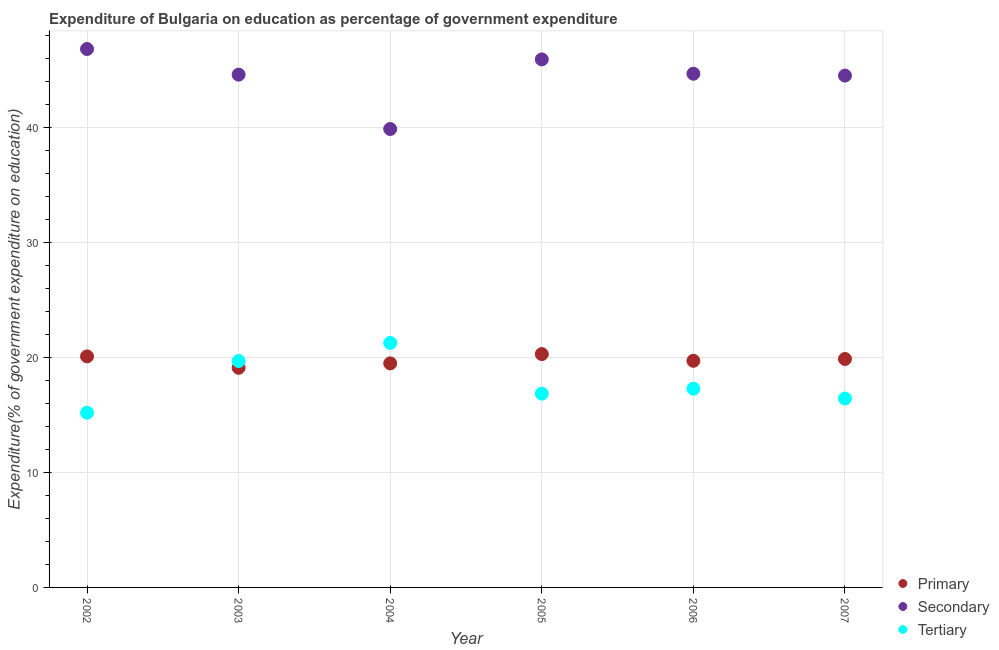How many different coloured dotlines are there?
Provide a short and direct response. 3. What is the expenditure on secondary education in 2005?
Your answer should be compact. 45.94. Across all years, what is the maximum expenditure on primary education?
Ensure brevity in your answer.  20.3. Across all years, what is the minimum expenditure on secondary education?
Provide a short and direct response. 39.88. In which year was the expenditure on secondary education maximum?
Your answer should be very brief. 2002. In which year was the expenditure on primary education minimum?
Your response must be concise. 2003. What is the total expenditure on secondary education in the graph?
Your answer should be very brief. 266.48. What is the difference between the expenditure on tertiary education in 2002 and that in 2003?
Provide a short and direct response. -4.5. What is the difference between the expenditure on primary education in 2007 and the expenditure on tertiary education in 2006?
Offer a terse response. 2.58. What is the average expenditure on tertiary education per year?
Your answer should be compact. 17.79. In the year 2005, what is the difference between the expenditure on tertiary education and expenditure on secondary education?
Provide a succinct answer. -29.08. What is the ratio of the expenditure on primary education in 2002 to that in 2005?
Give a very brief answer. 0.99. What is the difference between the highest and the second highest expenditure on tertiary education?
Provide a succinct answer. 1.58. What is the difference between the highest and the lowest expenditure on secondary education?
Offer a terse response. 6.96. Is it the case that in every year, the sum of the expenditure on primary education and expenditure on secondary education is greater than the expenditure on tertiary education?
Your response must be concise. Yes. How many dotlines are there?
Your response must be concise. 3. How many legend labels are there?
Offer a very short reply. 3. How are the legend labels stacked?
Your answer should be very brief. Vertical. What is the title of the graph?
Provide a short and direct response. Expenditure of Bulgaria on education as percentage of government expenditure. What is the label or title of the X-axis?
Make the answer very short. Year. What is the label or title of the Y-axis?
Give a very brief answer. Expenditure(% of government expenditure on education). What is the Expenditure(% of government expenditure on education) in Primary in 2002?
Keep it short and to the point. 20.1. What is the Expenditure(% of government expenditure on education) of Secondary in 2002?
Give a very brief answer. 46.84. What is the Expenditure(% of government expenditure on education) in Tertiary in 2002?
Keep it short and to the point. 15.19. What is the Expenditure(% of government expenditure on education) in Primary in 2003?
Offer a terse response. 19.11. What is the Expenditure(% of government expenditure on education) of Secondary in 2003?
Offer a terse response. 44.61. What is the Expenditure(% of government expenditure on education) in Tertiary in 2003?
Keep it short and to the point. 19.7. What is the Expenditure(% of government expenditure on education) in Primary in 2004?
Your response must be concise. 19.49. What is the Expenditure(% of government expenditure on education) of Secondary in 2004?
Offer a very short reply. 39.88. What is the Expenditure(% of government expenditure on education) of Tertiary in 2004?
Offer a very short reply. 21.27. What is the Expenditure(% of government expenditure on education) of Primary in 2005?
Offer a terse response. 20.3. What is the Expenditure(% of government expenditure on education) in Secondary in 2005?
Give a very brief answer. 45.94. What is the Expenditure(% of government expenditure on education) in Tertiary in 2005?
Provide a succinct answer. 16.86. What is the Expenditure(% of government expenditure on education) in Primary in 2006?
Your answer should be compact. 19.72. What is the Expenditure(% of government expenditure on education) in Secondary in 2006?
Offer a terse response. 44.69. What is the Expenditure(% of government expenditure on education) in Tertiary in 2006?
Offer a very short reply. 17.29. What is the Expenditure(% of government expenditure on education) of Primary in 2007?
Provide a short and direct response. 19.87. What is the Expenditure(% of government expenditure on education) in Secondary in 2007?
Offer a very short reply. 44.53. What is the Expenditure(% of government expenditure on education) of Tertiary in 2007?
Provide a short and direct response. 16.43. Across all years, what is the maximum Expenditure(% of government expenditure on education) in Primary?
Make the answer very short. 20.3. Across all years, what is the maximum Expenditure(% of government expenditure on education) of Secondary?
Your response must be concise. 46.84. Across all years, what is the maximum Expenditure(% of government expenditure on education) of Tertiary?
Keep it short and to the point. 21.27. Across all years, what is the minimum Expenditure(% of government expenditure on education) in Primary?
Provide a short and direct response. 19.11. Across all years, what is the minimum Expenditure(% of government expenditure on education) of Secondary?
Your answer should be very brief. 39.88. Across all years, what is the minimum Expenditure(% of government expenditure on education) of Tertiary?
Your answer should be compact. 15.19. What is the total Expenditure(% of government expenditure on education) of Primary in the graph?
Provide a succinct answer. 118.59. What is the total Expenditure(% of government expenditure on education) of Secondary in the graph?
Offer a terse response. 266.48. What is the total Expenditure(% of government expenditure on education) in Tertiary in the graph?
Ensure brevity in your answer.  106.74. What is the difference between the Expenditure(% of government expenditure on education) in Primary in 2002 and that in 2003?
Make the answer very short. 0.99. What is the difference between the Expenditure(% of government expenditure on education) in Secondary in 2002 and that in 2003?
Keep it short and to the point. 2.23. What is the difference between the Expenditure(% of government expenditure on education) of Tertiary in 2002 and that in 2003?
Offer a terse response. -4.5. What is the difference between the Expenditure(% of government expenditure on education) of Primary in 2002 and that in 2004?
Your response must be concise. 0.61. What is the difference between the Expenditure(% of government expenditure on education) in Secondary in 2002 and that in 2004?
Keep it short and to the point. 6.96. What is the difference between the Expenditure(% of government expenditure on education) of Tertiary in 2002 and that in 2004?
Your response must be concise. -6.08. What is the difference between the Expenditure(% of government expenditure on education) in Primary in 2002 and that in 2005?
Offer a terse response. -0.2. What is the difference between the Expenditure(% of government expenditure on education) of Secondary in 2002 and that in 2005?
Keep it short and to the point. 0.9. What is the difference between the Expenditure(% of government expenditure on education) of Tertiary in 2002 and that in 2005?
Provide a short and direct response. -1.67. What is the difference between the Expenditure(% of government expenditure on education) of Primary in 2002 and that in 2006?
Ensure brevity in your answer.  0.38. What is the difference between the Expenditure(% of government expenditure on education) in Secondary in 2002 and that in 2006?
Offer a terse response. 2.15. What is the difference between the Expenditure(% of government expenditure on education) in Tertiary in 2002 and that in 2006?
Offer a very short reply. -2.09. What is the difference between the Expenditure(% of government expenditure on education) in Primary in 2002 and that in 2007?
Your answer should be compact. 0.23. What is the difference between the Expenditure(% of government expenditure on education) in Secondary in 2002 and that in 2007?
Offer a terse response. 2.31. What is the difference between the Expenditure(% of government expenditure on education) in Tertiary in 2002 and that in 2007?
Your response must be concise. -1.24. What is the difference between the Expenditure(% of government expenditure on education) in Primary in 2003 and that in 2004?
Offer a very short reply. -0.39. What is the difference between the Expenditure(% of government expenditure on education) of Secondary in 2003 and that in 2004?
Your answer should be compact. 4.73. What is the difference between the Expenditure(% of government expenditure on education) of Tertiary in 2003 and that in 2004?
Ensure brevity in your answer.  -1.58. What is the difference between the Expenditure(% of government expenditure on education) in Primary in 2003 and that in 2005?
Offer a terse response. -1.19. What is the difference between the Expenditure(% of government expenditure on education) of Secondary in 2003 and that in 2005?
Provide a short and direct response. -1.33. What is the difference between the Expenditure(% of government expenditure on education) of Tertiary in 2003 and that in 2005?
Offer a terse response. 2.84. What is the difference between the Expenditure(% of government expenditure on education) of Primary in 2003 and that in 2006?
Keep it short and to the point. -0.61. What is the difference between the Expenditure(% of government expenditure on education) of Secondary in 2003 and that in 2006?
Offer a very short reply. -0.08. What is the difference between the Expenditure(% of government expenditure on education) of Tertiary in 2003 and that in 2006?
Give a very brief answer. 2.41. What is the difference between the Expenditure(% of government expenditure on education) in Primary in 2003 and that in 2007?
Your answer should be compact. -0.77. What is the difference between the Expenditure(% of government expenditure on education) in Secondary in 2003 and that in 2007?
Your answer should be very brief. 0.08. What is the difference between the Expenditure(% of government expenditure on education) in Tertiary in 2003 and that in 2007?
Your answer should be very brief. 3.26. What is the difference between the Expenditure(% of government expenditure on education) of Primary in 2004 and that in 2005?
Give a very brief answer. -0.81. What is the difference between the Expenditure(% of government expenditure on education) in Secondary in 2004 and that in 2005?
Your answer should be compact. -6.05. What is the difference between the Expenditure(% of government expenditure on education) in Tertiary in 2004 and that in 2005?
Ensure brevity in your answer.  4.41. What is the difference between the Expenditure(% of government expenditure on education) in Primary in 2004 and that in 2006?
Keep it short and to the point. -0.22. What is the difference between the Expenditure(% of government expenditure on education) of Secondary in 2004 and that in 2006?
Ensure brevity in your answer.  -4.81. What is the difference between the Expenditure(% of government expenditure on education) in Tertiary in 2004 and that in 2006?
Provide a short and direct response. 3.98. What is the difference between the Expenditure(% of government expenditure on education) in Primary in 2004 and that in 2007?
Ensure brevity in your answer.  -0.38. What is the difference between the Expenditure(% of government expenditure on education) in Secondary in 2004 and that in 2007?
Ensure brevity in your answer.  -4.65. What is the difference between the Expenditure(% of government expenditure on education) of Tertiary in 2004 and that in 2007?
Offer a terse response. 4.84. What is the difference between the Expenditure(% of government expenditure on education) in Primary in 2005 and that in 2006?
Ensure brevity in your answer.  0.58. What is the difference between the Expenditure(% of government expenditure on education) in Secondary in 2005 and that in 2006?
Your response must be concise. 1.25. What is the difference between the Expenditure(% of government expenditure on education) of Tertiary in 2005 and that in 2006?
Offer a very short reply. -0.43. What is the difference between the Expenditure(% of government expenditure on education) in Primary in 2005 and that in 2007?
Provide a short and direct response. 0.43. What is the difference between the Expenditure(% of government expenditure on education) of Secondary in 2005 and that in 2007?
Keep it short and to the point. 1.41. What is the difference between the Expenditure(% of government expenditure on education) of Tertiary in 2005 and that in 2007?
Give a very brief answer. 0.43. What is the difference between the Expenditure(% of government expenditure on education) of Primary in 2006 and that in 2007?
Provide a short and direct response. -0.16. What is the difference between the Expenditure(% of government expenditure on education) of Secondary in 2006 and that in 2007?
Make the answer very short. 0.16. What is the difference between the Expenditure(% of government expenditure on education) in Tertiary in 2006 and that in 2007?
Make the answer very short. 0.86. What is the difference between the Expenditure(% of government expenditure on education) in Primary in 2002 and the Expenditure(% of government expenditure on education) in Secondary in 2003?
Offer a very short reply. -24.51. What is the difference between the Expenditure(% of government expenditure on education) of Primary in 2002 and the Expenditure(% of government expenditure on education) of Tertiary in 2003?
Your response must be concise. 0.4. What is the difference between the Expenditure(% of government expenditure on education) of Secondary in 2002 and the Expenditure(% of government expenditure on education) of Tertiary in 2003?
Give a very brief answer. 27.14. What is the difference between the Expenditure(% of government expenditure on education) of Primary in 2002 and the Expenditure(% of government expenditure on education) of Secondary in 2004?
Provide a short and direct response. -19.78. What is the difference between the Expenditure(% of government expenditure on education) of Primary in 2002 and the Expenditure(% of government expenditure on education) of Tertiary in 2004?
Ensure brevity in your answer.  -1.17. What is the difference between the Expenditure(% of government expenditure on education) of Secondary in 2002 and the Expenditure(% of government expenditure on education) of Tertiary in 2004?
Make the answer very short. 25.57. What is the difference between the Expenditure(% of government expenditure on education) in Primary in 2002 and the Expenditure(% of government expenditure on education) in Secondary in 2005?
Your response must be concise. -25.84. What is the difference between the Expenditure(% of government expenditure on education) in Primary in 2002 and the Expenditure(% of government expenditure on education) in Tertiary in 2005?
Your answer should be very brief. 3.24. What is the difference between the Expenditure(% of government expenditure on education) in Secondary in 2002 and the Expenditure(% of government expenditure on education) in Tertiary in 2005?
Give a very brief answer. 29.98. What is the difference between the Expenditure(% of government expenditure on education) in Primary in 2002 and the Expenditure(% of government expenditure on education) in Secondary in 2006?
Ensure brevity in your answer.  -24.59. What is the difference between the Expenditure(% of government expenditure on education) in Primary in 2002 and the Expenditure(% of government expenditure on education) in Tertiary in 2006?
Your response must be concise. 2.81. What is the difference between the Expenditure(% of government expenditure on education) in Secondary in 2002 and the Expenditure(% of government expenditure on education) in Tertiary in 2006?
Provide a short and direct response. 29.55. What is the difference between the Expenditure(% of government expenditure on education) in Primary in 2002 and the Expenditure(% of government expenditure on education) in Secondary in 2007?
Your answer should be very brief. -24.43. What is the difference between the Expenditure(% of government expenditure on education) in Primary in 2002 and the Expenditure(% of government expenditure on education) in Tertiary in 2007?
Keep it short and to the point. 3.67. What is the difference between the Expenditure(% of government expenditure on education) in Secondary in 2002 and the Expenditure(% of government expenditure on education) in Tertiary in 2007?
Keep it short and to the point. 30.41. What is the difference between the Expenditure(% of government expenditure on education) in Primary in 2003 and the Expenditure(% of government expenditure on education) in Secondary in 2004?
Offer a very short reply. -20.77. What is the difference between the Expenditure(% of government expenditure on education) of Primary in 2003 and the Expenditure(% of government expenditure on education) of Tertiary in 2004?
Make the answer very short. -2.17. What is the difference between the Expenditure(% of government expenditure on education) in Secondary in 2003 and the Expenditure(% of government expenditure on education) in Tertiary in 2004?
Offer a very short reply. 23.34. What is the difference between the Expenditure(% of government expenditure on education) in Primary in 2003 and the Expenditure(% of government expenditure on education) in Secondary in 2005?
Keep it short and to the point. -26.83. What is the difference between the Expenditure(% of government expenditure on education) of Primary in 2003 and the Expenditure(% of government expenditure on education) of Tertiary in 2005?
Give a very brief answer. 2.25. What is the difference between the Expenditure(% of government expenditure on education) in Secondary in 2003 and the Expenditure(% of government expenditure on education) in Tertiary in 2005?
Provide a succinct answer. 27.75. What is the difference between the Expenditure(% of government expenditure on education) in Primary in 2003 and the Expenditure(% of government expenditure on education) in Secondary in 2006?
Provide a succinct answer. -25.58. What is the difference between the Expenditure(% of government expenditure on education) of Primary in 2003 and the Expenditure(% of government expenditure on education) of Tertiary in 2006?
Offer a terse response. 1.82. What is the difference between the Expenditure(% of government expenditure on education) in Secondary in 2003 and the Expenditure(% of government expenditure on education) in Tertiary in 2006?
Offer a terse response. 27.32. What is the difference between the Expenditure(% of government expenditure on education) of Primary in 2003 and the Expenditure(% of government expenditure on education) of Secondary in 2007?
Keep it short and to the point. -25.42. What is the difference between the Expenditure(% of government expenditure on education) in Primary in 2003 and the Expenditure(% of government expenditure on education) in Tertiary in 2007?
Make the answer very short. 2.67. What is the difference between the Expenditure(% of government expenditure on education) of Secondary in 2003 and the Expenditure(% of government expenditure on education) of Tertiary in 2007?
Your answer should be very brief. 28.18. What is the difference between the Expenditure(% of government expenditure on education) in Primary in 2004 and the Expenditure(% of government expenditure on education) in Secondary in 2005?
Your answer should be very brief. -26.44. What is the difference between the Expenditure(% of government expenditure on education) of Primary in 2004 and the Expenditure(% of government expenditure on education) of Tertiary in 2005?
Offer a terse response. 2.63. What is the difference between the Expenditure(% of government expenditure on education) of Secondary in 2004 and the Expenditure(% of government expenditure on education) of Tertiary in 2005?
Keep it short and to the point. 23.02. What is the difference between the Expenditure(% of government expenditure on education) of Primary in 2004 and the Expenditure(% of government expenditure on education) of Secondary in 2006?
Your response must be concise. -25.2. What is the difference between the Expenditure(% of government expenditure on education) in Primary in 2004 and the Expenditure(% of government expenditure on education) in Tertiary in 2006?
Offer a very short reply. 2.2. What is the difference between the Expenditure(% of government expenditure on education) of Secondary in 2004 and the Expenditure(% of government expenditure on education) of Tertiary in 2006?
Provide a succinct answer. 22.59. What is the difference between the Expenditure(% of government expenditure on education) in Primary in 2004 and the Expenditure(% of government expenditure on education) in Secondary in 2007?
Offer a terse response. -25.04. What is the difference between the Expenditure(% of government expenditure on education) in Primary in 2004 and the Expenditure(% of government expenditure on education) in Tertiary in 2007?
Make the answer very short. 3.06. What is the difference between the Expenditure(% of government expenditure on education) of Secondary in 2004 and the Expenditure(% of government expenditure on education) of Tertiary in 2007?
Keep it short and to the point. 23.45. What is the difference between the Expenditure(% of government expenditure on education) of Primary in 2005 and the Expenditure(% of government expenditure on education) of Secondary in 2006?
Give a very brief answer. -24.39. What is the difference between the Expenditure(% of government expenditure on education) of Primary in 2005 and the Expenditure(% of government expenditure on education) of Tertiary in 2006?
Keep it short and to the point. 3.01. What is the difference between the Expenditure(% of government expenditure on education) in Secondary in 2005 and the Expenditure(% of government expenditure on education) in Tertiary in 2006?
Give a very brief answer. 28.65. What is the difference between the Expenditure(% of government expenditure on education) in Primary in 2005 and the Expenditure(% of government expenditure on education) in Secondary in 2007?
Ensure brevity in your answer.  -24.23. What is the difference between the Expenditure(% of government expenditure on education) in Primary in 2005 and the Expenditure(% of government expenditure on education) in Tertiary in 2007?
Make the answer very short. 3.87. What is the difference between the Expenditure(% of government expenditure on education) of Secondary in 2005 and the Expenditure(% of government expenditure on education) of Tertiary in 2007?
Your answer should be compact. 29.5. What is the difference between the Expenditure(% of government expenditure on education) of Primary in 2006 and the Expenditure(% of government expenditure on education) of Secondary in 2007?
Your answer should be very brief. -24.81. What is the difference between the Expenditure(% of government expenditure on education) of Primary in 2006 and the Expenditure(% of government expenditure on education) of Tertiary in 2007?
Your answer should be very brief. 3.28. What is the difference between the Expenditure(% of government expenditure on education) of Secondary in 2006 and the Expenditure(% of government expenditure on education) of Tertiary in 2007?
Make the answer very short. 28.26. What is the average Expenditure(% of government expenditure on education) in Primary per year?
Provide a succinct answer. 19.76. What is the average Expenditure(% of government expenditure on education) of Secondary per year?
Provide a succinct answer. 44.41. What is the average Expenditure(% of government expenditure on education) in Tertiary per year?
Provide a short and direct response. 17.79. In the year 2002, what is the difference between the Expenditure(% of government expenditure on education) of Primary and Expenditure(% of government expenditure on education) of Secondary?
Keep it short and to the point. -26.74. In the year 2002, what is the difference between the Expenditure(% of government expenditure on education) of Primary and Expenditure(% of government expenditure on education) of Tertiary?
Make the answer very short. 4.9. In the year 2002, what is the difference between the Expenditure(% of government expenditure on education) in Secondary and Expenditure(% of government expenditure on education) in Tertiary?
Offer a very short reply. 31.65. In the year 2003, what is the difference between the Expenditure(% of government expenditure on education) in Primary and Expenditure(% of government expenditure on education) in Secondary?
Keep it short and to the point. -25.5. In the year 2003, what is the difference between the Expenditure(% of government expenditure on education) of Primary and Expenditure(% of government expenditure on education) of Tertiary?
Provide a succinct answer. -0.59. In the year 2003, what is the difference between the Expenditure(% of government expenditure on education) of Secondary and Expenditure(% of government expenditure on education) of Tertiary?
Provide a succinct answer. 24.91. In the year 2004, what is the difference between the Expenditure(% of government expenditure on education) of Primary and Expenditure(% of government expenditure on education) of Secondary?
Provide a short and direct response. -20.39. In the year 2004, what is the difference between the Expenditure(% of government expenditure on education) of Primary and Expenditure(% of government expenditure on education) of Tertiary?
Keep it short and to the point. -1.78. In the year 2004, what is the difference between the Expenditure(% of government expenditure on education) of Secondary and Expenditure(% of government expenditure on education) of Tertiary?
Keep it short and to the point. 18.61. In the year 2005, what is the difference between the Expenditure(% of government expenditure on education) in Primary and Expenditure(% of government expenditure on education) in Secondary?
Give a very brief answer. -25.64. In the year 2005, what is the difference between the Expenditure(% of government expenditure on education) of Primary and Expenditure(% of government expenditure on education) of Tertiary?
Give a very brief answer. 3.44. In the year 2005, what is the difference between the Expenditure(% of government expenditure on education) in Secondary and Expenditure(% of government expenditure on education) in Tertiary?
Keep it short and to the point. 29.08. In the year 2006, what is the difference between the Expenditure(% of government expenditure on education) of Primary and Expenditure(% of government expenditure on education) of Secondary?
Ensure brevity in your answer.  -24.97. In the year 2006, what is the difference between the Expenditure(% of government expenditure on education) in Primary and Expenditure(% of government expenditure on education) in Tertiary?
Keep it short and to the point. 2.43. In the year 2006, what is the difference between the Expenditure(% of government expenditure on education) of Secondary and Expenditure(% of government expenditure on education) of Tertiary?
Offer a terse response. 27.4. In the year 2007, what is the difference between the Expenditure(% of government expenditure on education) of Primary and Expenditure(% of government expenditure on education) of Secondary?
Your response must be concise. -24.66. In the year 2007, what is the difference between the Expenditure(% of government expenditure on education) of Primary and Expenditure(% of government expenditure on education) of Tertiary?
Your answer should be compact. 3.44. In the year 2007, what is the difference between the Expenditure(% of government expenditure on education) of Secondary and Expenditure(% of government expenditure on education) of Tertiary?
Ensure brevity in your answer.  28.1. What is the ratio of the Expenditure(% of government expenditure on education) of Primary in 2002 to that in 2003?
Offer a very short reply. 1.05. What is the ratio of the Expenditure(% of government expenditure on education) of Tertiary in 2002 to that in 2003?
Keep it short and to the point. 0.77. What is the ratio of the Expenditure(% of government expenditure on education) in Primary in 2002 to that in 2004?
Ensure brevity in your answer.  1.03. What is the ratio of the Expenditure(% of government expenditure on education) in Secondary in 2002 to that in 2004?
Your answer should be compact. 1.17. What is the ratio of the Expenditure(% of government expenditure on education) of Primary in 2002 to that in 2005?
Your answer should be compact. 0.99. What is the ratio of the Expenditure(% of government expenditure on education) of Secondary in 2002 to that in 2005?
Ensure brevity in your answer.  1.02. What is the ratio of the Expenditure(% of government expenditure on education) of Tertiary in 2002 to that in 2005?
Your response must be concise. 0.9. What is the ratio of the Expenditure(% of government expenditure on education) in Primary in 2002 to that in 2006?
Ensure brevity in your answer.  1.02. What is the ratio of the Expenditure(% of government expenditure on education) in Secondary in 2002 to that in 2006?
Offer a very short reply. 1.05. What is the ratio of the Expenditure(% of government expenditure on education) of Tertiary in 2002 to that in 2006?
Keep it short and to the point. 0.88. What is the ratio of the Expenditure(% of government expenditure on education) in Primary in 2002 to that in 2007?
Your answer should be compact. 1.01. What is the ratio of the Expenditure(% of government expenditure on education) of Secondary in 2002 to that in 2007?
Offer a terse response. 1.05. What is the ratio of the Expenditure(% of government expenditure on education) in Tertiary in 2002 to that in 2007?
Give a very brief answer. 0.92. What is the ratio of the Expenditure(% of government expenditure on education) of Primary in 2003 to that in 2004?
Ensure brevity in your answer.  0.98. What is the ratio of the Expenditure(% of government expenditure on education) of Secondary in 2003 to that in 2004?
Provide a short and direct response. 1.12. What is the ratio of the Expenditure(% of government expenditure on education) in Tertiary in 2003 to that in 2004?
Keep it short and to the point. 0.93. What is the ratio of the Expenditure(% of government expenditure on education) of Primary in 2003 to that in 2005?
Offer a terse response. 0.94. What is the ratio of the Expenditure(% of government expenditure on education) in Secondary in 2003 to that in 2005?
Give a very brief answer. 0.97. What is the ratio of the Expenditure(% of government expenditure on education) of Tertiary in 2003 to that in 2005?
Your answer should be compact. 1.17. What is the ratio of the Expenditure(% of government expenditure on education) of Primary in 2003 to that in 2006?
Keep it short and to the point. 0.97. What is the ratio of the Expenditure(% of government expenditure on education) in Secondary in 2003 to that in 2006?
Provide a succinct answer. 1. What is the ratio of the Expenditure(% of government expenditure on education) of Tertiary in 2003 to that in 2006?
Provide a succinct answer. 1.14. What is the ratio of the Expenditure(% of government expenditure on education) of Primary in 2003 to that in 2007?
Keep it short and to the point. 0.96. What is the ratio of the Expenditure(% of government expenditure on education) of Secondary in 2003 to that in 2007?
Provide a short and direct response. 1. What is the ratio of the Expenditure(% of government expenditure on education) of Tertiary in 2003 to that in 2007?
Provide a short and direct response. 1.2. What is the ratio of the Expenditure(% of government expenditure on education) of Primary in 2004 to that in 2005?
Your answer should be compact. 0.96. What is the ratio of the Expenditure(% of government expenditure on education) in Secondary in 2004 to that in 2005?
Your answer should be compact. 0.87. What is the ratio of the Expenditure(% of government expenditure on education) in Tertiary in 2004 to that in 2005?
Your answer should be compact. 1.26. What is the ratio of the Expenditure(% of government expenditure on education) in Primary in 2004 to that in 2006?
Your answer should be compact. 0.99. What is the ratio of the Expenditure(% of government expenditure on education) in Secondary in 2004 to that in 2006?
Offer a very short reply. 0.89. What is the ratio of the Expenditure(% of government expenditure on education) of Tertiary in 2004 to that in 2006?
Provide a succinct answer. 1.23. What is the ratio of the Expenditure(% of government expenditure on education) of Primary in 2004 to that in 2007?
Offer a terse response. 0.98. What is the ratio of the Expenditure(% of government expenditure on education) in Secondary in 2004 to that in 2007?
Keep it short and to the point. 0.9. What is the ratio of the Expenditure(% of government expenditure on education) in Tertiary in 2004 to that in 2007?
Provide a short and direct response. 1.29. What is the ratio of the Expenditure(% of government expenditure on education) in Primary in 2005 to that in 2006?
Provide a short and direct response. 1.03. What is the ratio of the Expenditure(% of government expenditure on education) of Secondary in 2005 to that in 2006?
Ensure brevity in your answer.  1.03. What is the ratio of the Expenditure(% of government expenditure on education) in Tertiary in 2005 to that in 2006?
Ensure brevity in your answer.  0.98. What is the ratio of the Expenditure(% of government expenditure on education) of Primary in 2005 to that in 2007?
Provide a short and direct response. 1.02. What is the ratio of the Expenditure(% of government expenditure on education) of Secondary in 2005 to that in 2007?
Offer a very short reply. 1.03. What is the ratio of the Expenditure(% of government expenditure on education) in Secondary in 2006 to that in 2007?
Make the answer very short. 1. What is the ratio of the Expenditure(% of government expenditure on education) in Tertiary in 2006 to that in 2007?
Give a very brief answer. 1.05. What is the difference between the highest and the second highest Expenditure(% of government expenditure on education) of Primary?
Provide a short and direct response. 0.2. What is the difference between the highest and the second highest Expenditure(% of government expenditure on education) of Secondary?
Make the answer very short. 0.9. What is the difference between the highest and the second highest Expenditure(% of government expenditure on education) in Tertiary?
Offer a terse response. 1.58. What is the difference between the highest and the lowest Expenditure(% of government expenditure on education) in Primary?
Offer a very short reply. 1.19. What is the difference between the highest and the lowest Expenditure(% of government expenditure on education) of Secondary?
Provide a short and direct response. 6.96. What is the difference between the highest and the lowest Expenditure(% of government expenditure on education) of Tertiary?
Ensure brevity in your answer.  6.08. 